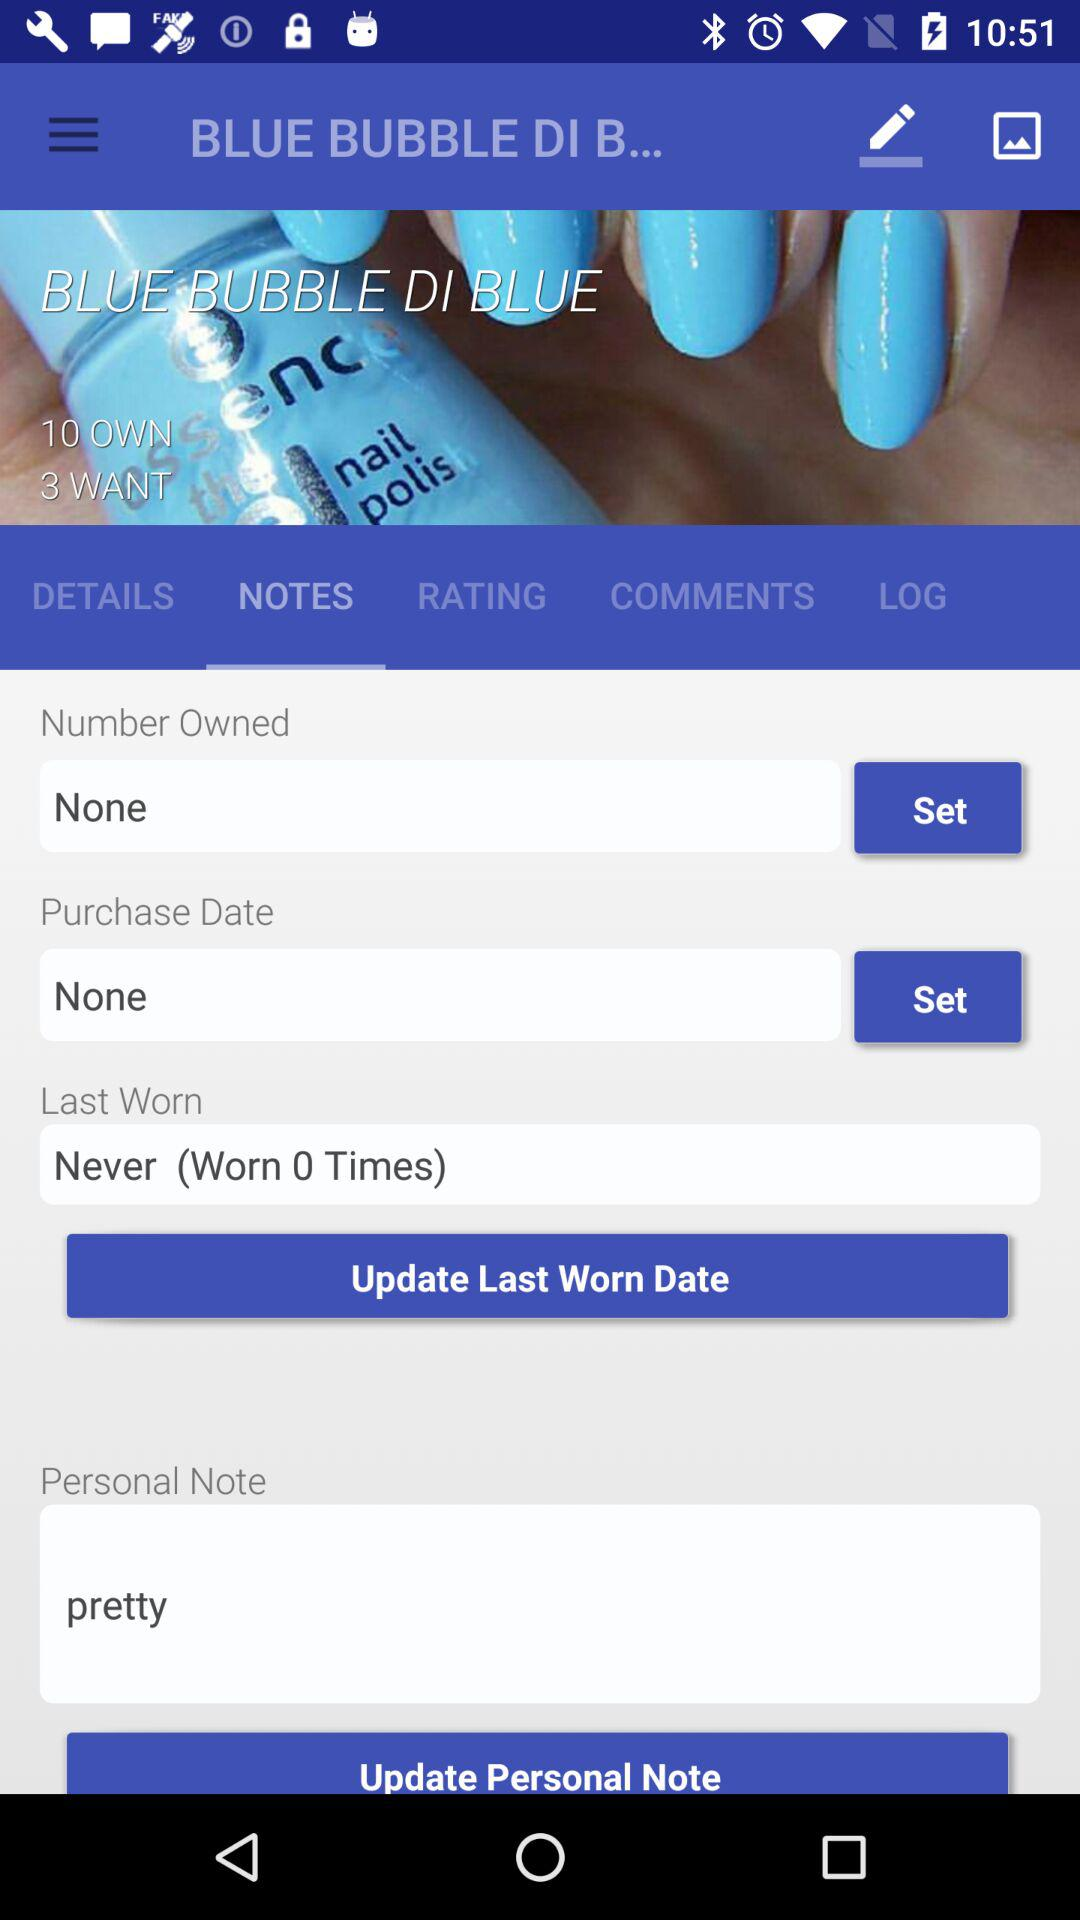What is the application name?
When the provided information is insufficient, respond with <no answer>. <no answer> 